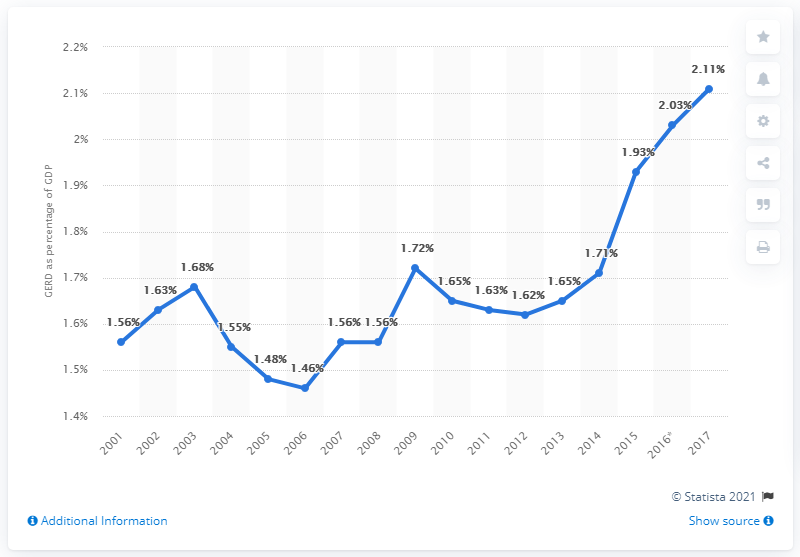Specify some key components in this picture. The difference between the highest GERD percentage from 2010 to 2013 and the average of those years is 0.31875. According to estimates, Norway's GDP spent on research and development in 2017 was 2.11%. The blue line represents 17 data counts. 